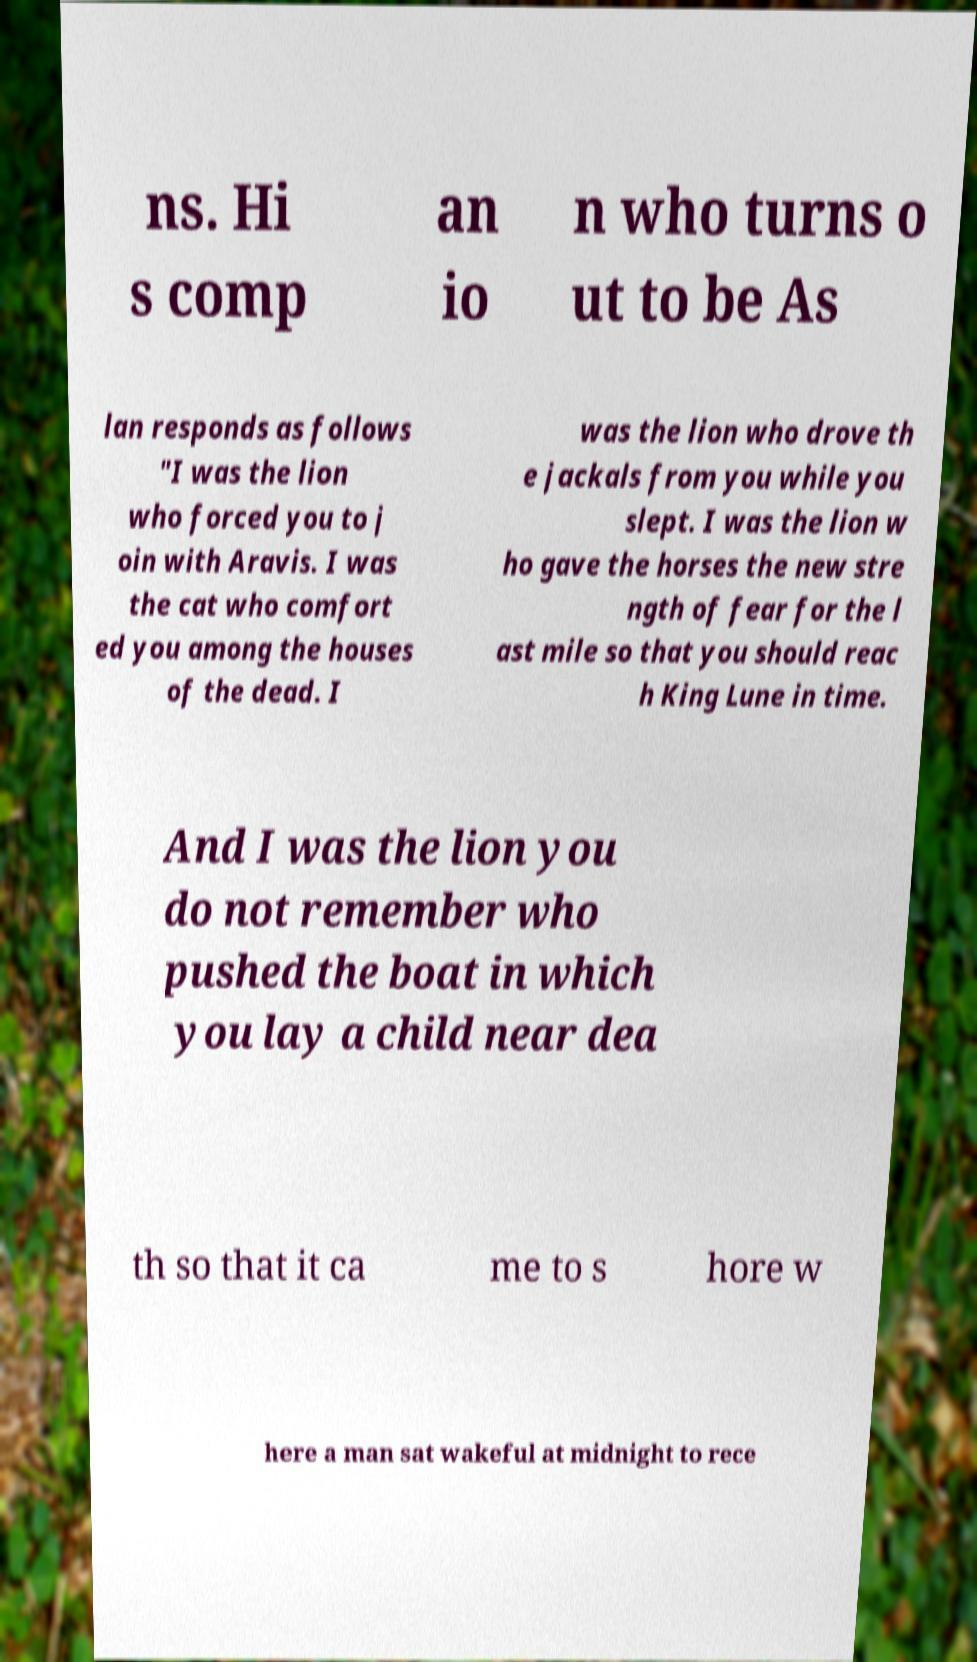Please identify and transcribe the text found in this image. ns. Hi s comp an io n who turns o ut to be As lan responds as follows "I was the lion who forced you to j oin with Aravis. I was the cat who comfort ed you among the houses of the dead. I was the lion who drove th e jackals from you while you slept. I was the lion w ho gave the horses the new stre ngth of fear for the l ast mile so that you should reac h King Lune in time. And I was the lion you do not remember who pushed the boat in which you lay a child near dea th so that it ca me to s hore w here a man sat wakeful at midnight to rece 